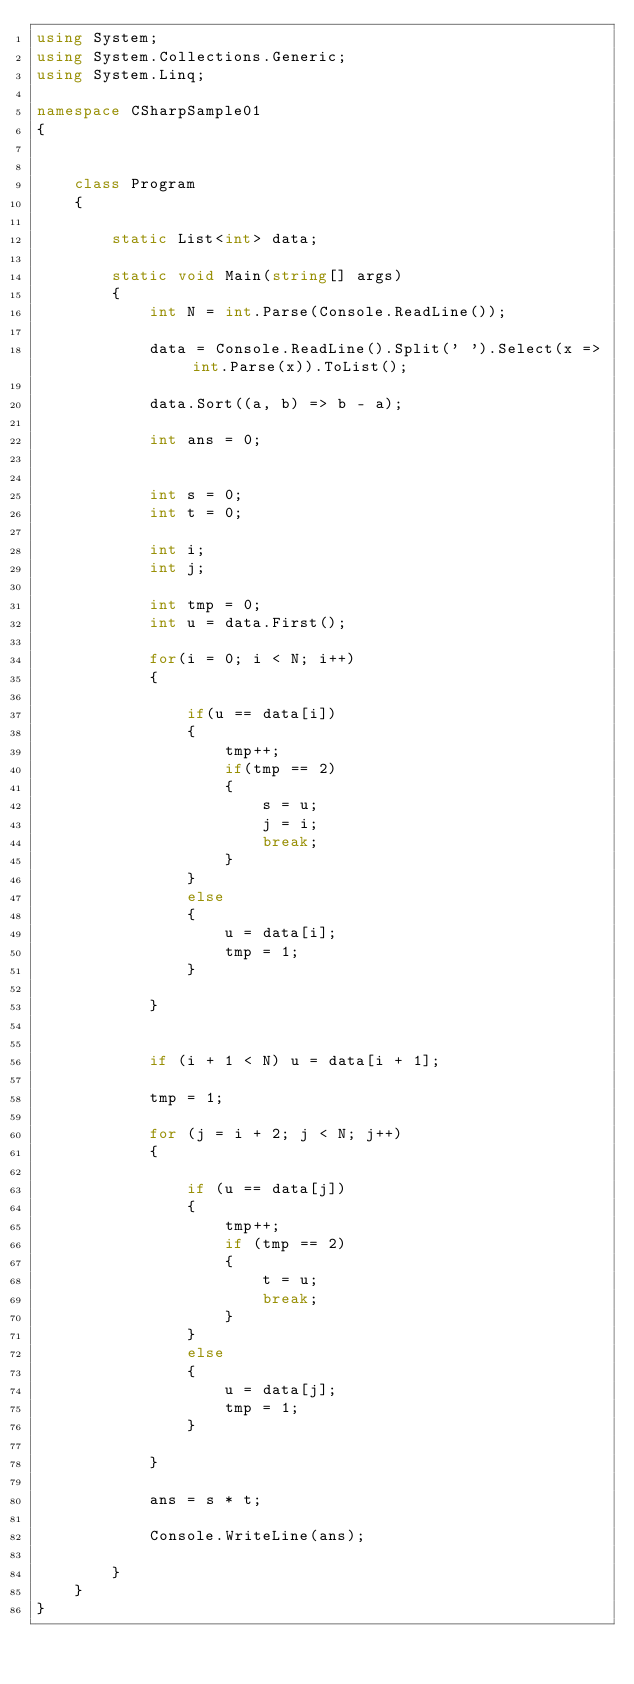<code> <loc_0><loc_0><loc_500><loc_500><_C#_>using System;
using System.Collections.Generic;
using System.Linq;

namespace CSharpSample01
{
    

    class Program
    {

        static List<int> data;

        static void Main(string[] args)
        {
            int N = int.Parse(Console.ReadLine());

            data = Console.ReadLine().Split(' ').Select(x => int.Parse(x)).ToList();

            data.Sort((a, b) => b - a);

            int ans = 0;


            int s = 0;
            int t = 0;

            int i;
            int j;

            int tmp = 0;
            int u = data.First();

            for(i = 0; i < N; i++)
            {
                
                if(u == data[i])
                {
                    tmp++;
                    if(tmp == 2)
                    {
                        s = u;
                        j = i;
                        break;
                    }
                }
                else
                {
                    u = data[i];
                    tmp = 1;
                }
                
            }


            if (i + 1 < N) u = data[i + 1];

            tmp = 1;

            for (j = i + 2; j < N; j++)
            {

                if (u == data[j])
                {
                    tmp++;
                    if (tmp == 2)
                    {
                        t = u;                        
                        break;
                    }
                }
                else
                {
                    u = data[j];
                    tmp = 1;
                }

            }

            ans = s * t;
           
            Console.WriteLine(ans);            

        }
    }
}
</code> 